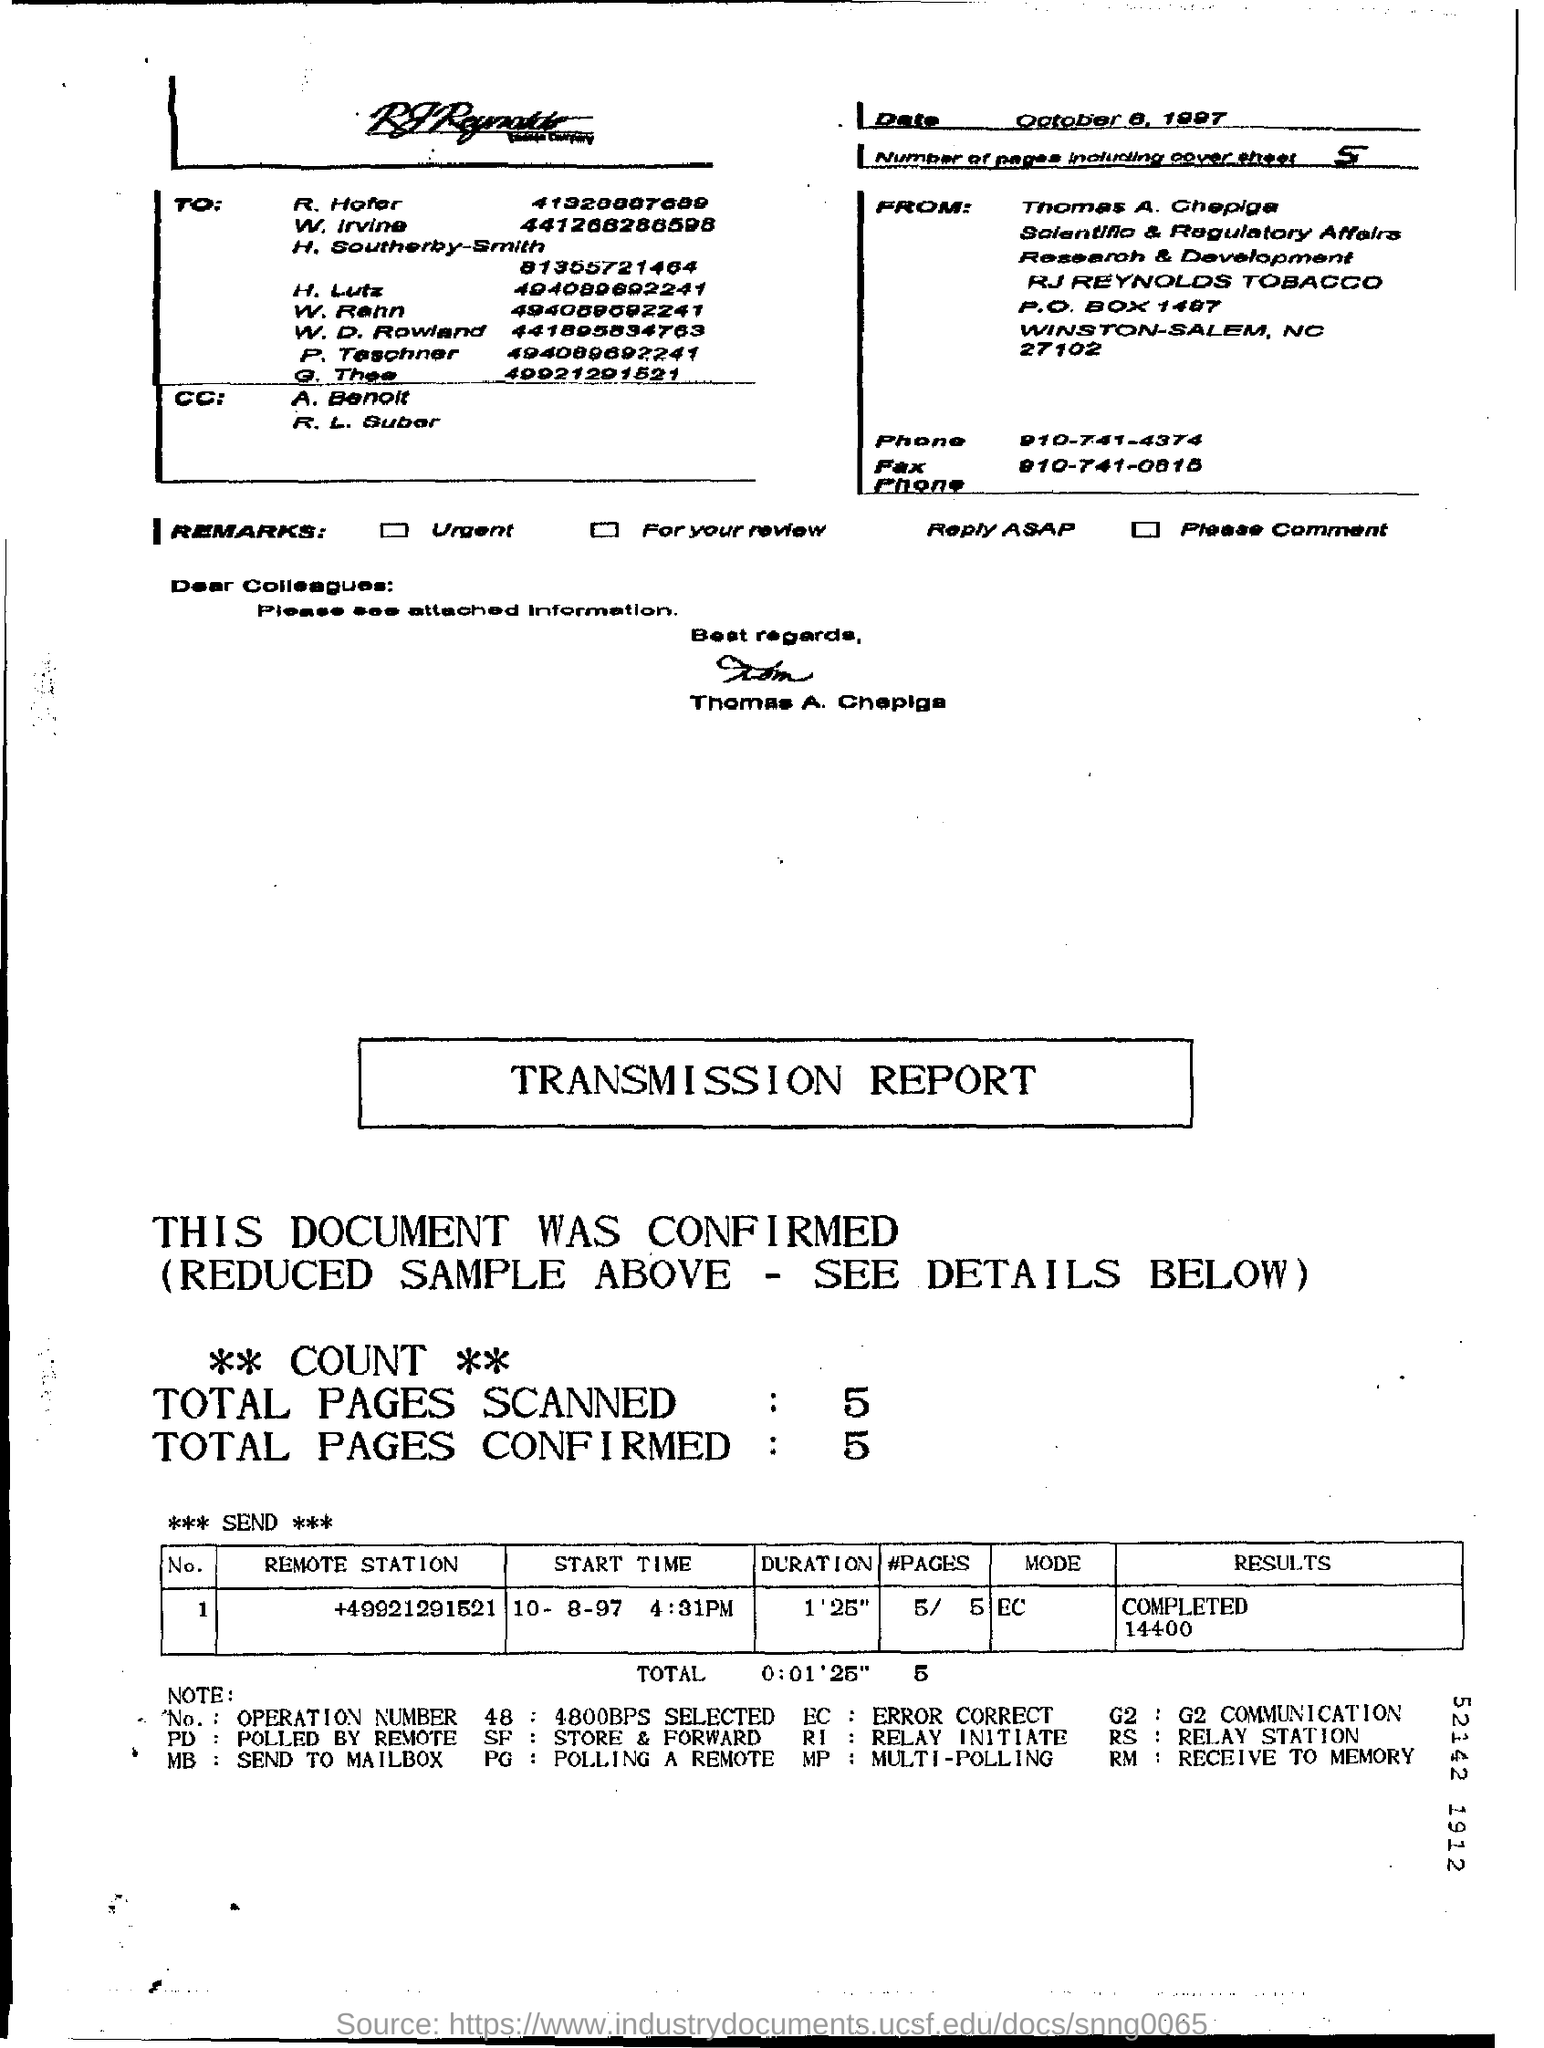Highlight a few significant elements in this photo. The acronym PD refers to "Polled by Remote," which is a method of gathering data from a group of individuals through a remote communication platform. There are a total of 5 pages, including the cover pages. The total number of pages scanned is 5.. The total number of pages confirmed is 5.. 